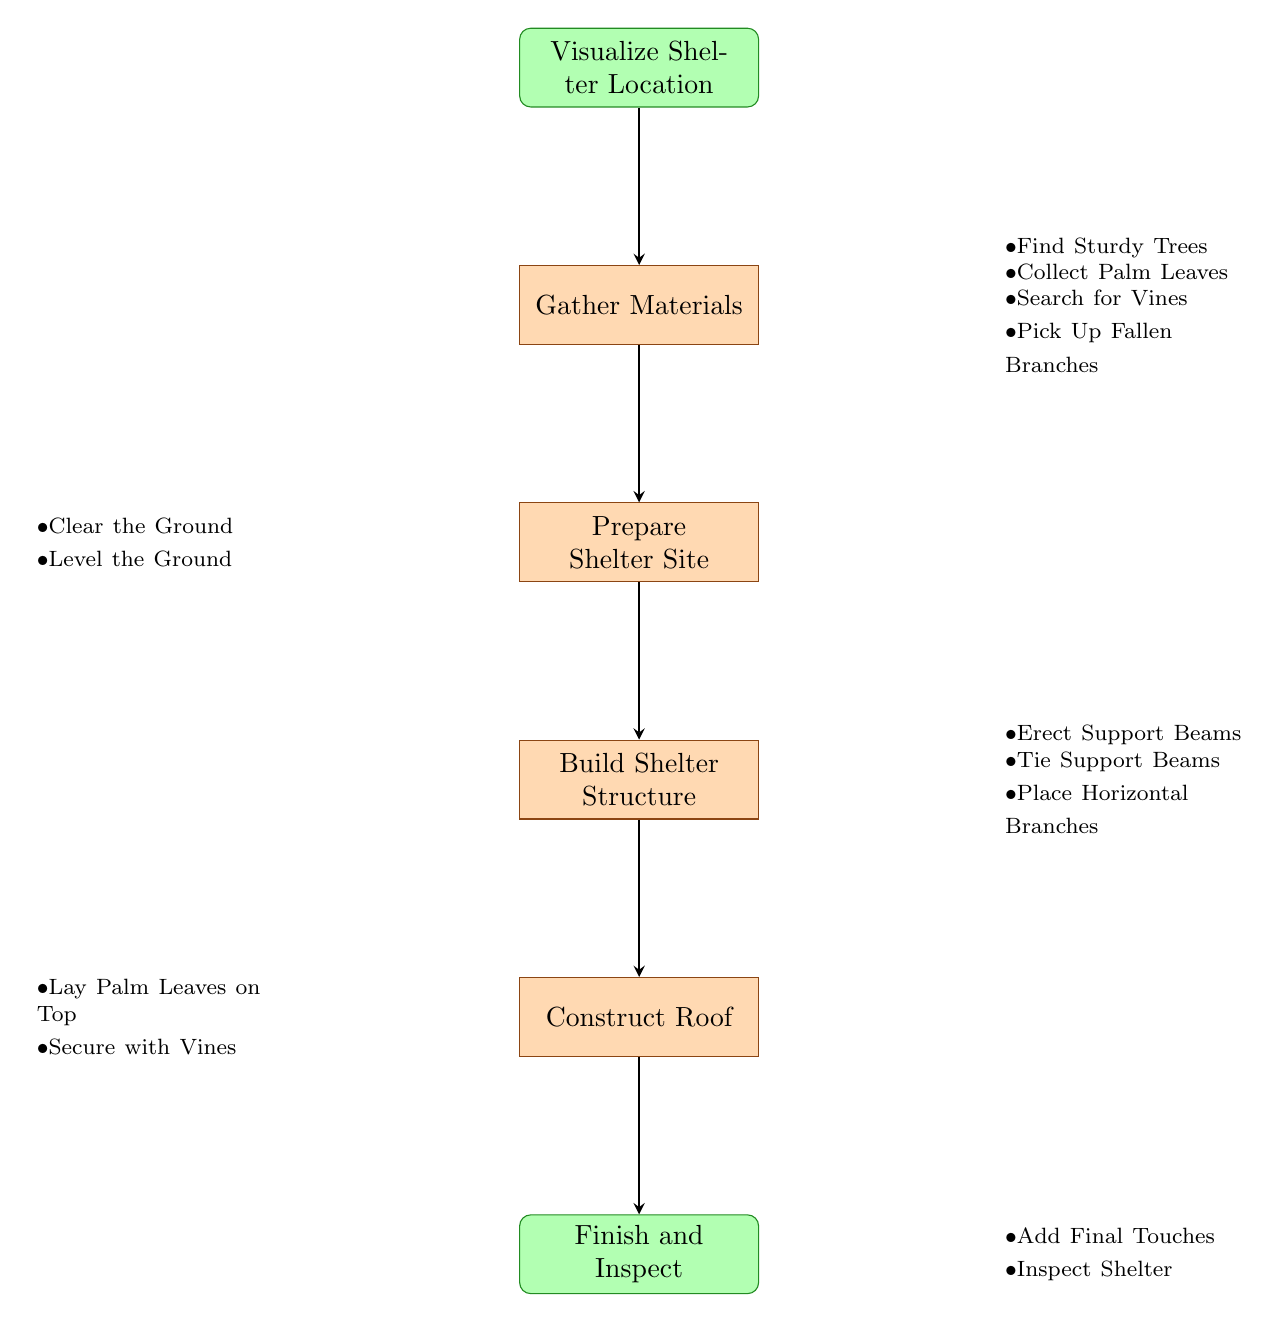What is the first step in building the shelter? The flowchart indicates that the first step is "Visualize Shelter Location," which is directly connected to the start node.
Answer: Visualize Shelter Location How many main steps are there in the shelter building process? The main steps in the flowchart are "Gather Materials," "Prepare Shelter Site," "Build Shelter Structure," "Construct Roof," and "Finish and Inspect," which totals five steps.
Answer: Five Which step comes immediately after preparing the shelter site? According to the flowchart, the step that follows "Prepare Shelter Site" is "Build Shelter Structure." This is derived from the arrows indicating the flow of the process.
Answer: Build Shelter Structure What materials are gathered in the first step? The first step includes gathering four materials: Sturdy Trees, Palm Leaves, Vines, and Fallen Branches, as outlined in the substeps of "Gather Materials."
Answer: Sturdy Trees, Palm Leaves, Vines, Fallen Branches What must be done after constructing the roof? After completing the "Construct Roof" step, the next action is to "Finish and Inspect," as indicated by the flow of the chart.
Answer: Finish and Inspect How are the support beams secured in the shelter structure? In the "Build Shelter Structure" step, support beams are secured by tying them together using vines, which is detailed in the substeps. Thus, the support beams are tied for stability.
Answer: Tie Support Beams Together What action is performed to ensure the ground is stable? To ensure stability, the action of "Level the Ground" is performed in the "Prepare Shelter Site" step. This is noted in the substeps detailing what needs to be done when preparing the site.
Answer: Level the Ground What are the final actions taken before completing the shelter? The final actions detailed in the "Finish and Inspect" step are "Add Final Touches" and "Inspect Shelter," which involves going through the last checks and adjustments.
Answer: Add Final Touches, Inspect Shelter 